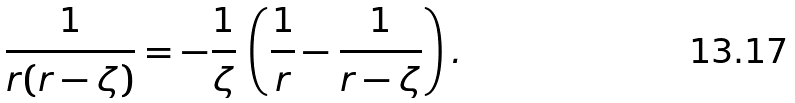<formula> <loc_0><loc_0><loc_500><loc_500>\frac { 1 } { r ( r - \zeta ) } = - \frac { 1 } { \zeta } \, \left ( \frac { 1 } { r } - \frac { 1 } { r - \zeta } \right ) .</formula> 